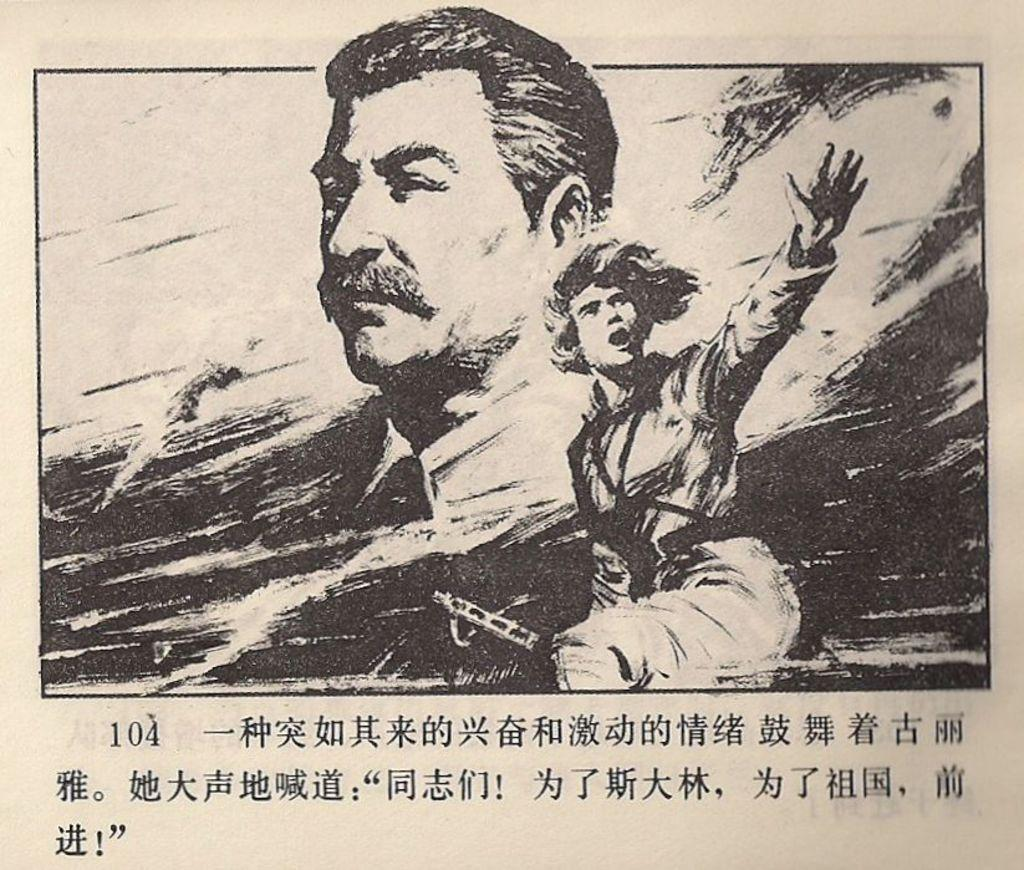What is featured in the picture? There is a poster in the picture. What can be seen on the poster? The poster contains pictures of men. Is there any text on the poster? Yes, there is text written at the bottom of the poster. Where is the library located in the image? There is no library present in the image; it only features a poster with pictures of men and text at the bottom. Can you tell me how many aunts are depicted on the poster? There are no aunts depicted on the poster; it only features pictures of men. 